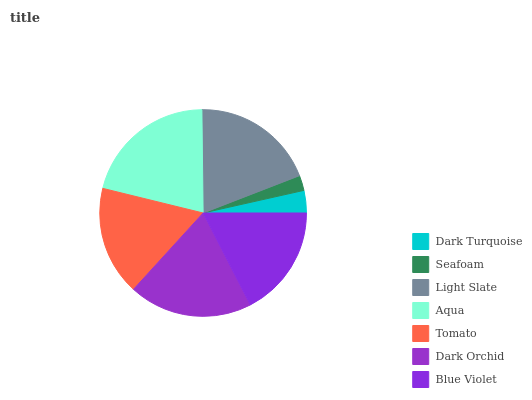Is Seafoam the minimum?
Answer yes or no. Yes. Is Aqua the maximum?
Answer yes or no. Yes. Is Light Slate the minimum?
Answer yes or no. No. Is Light Slate the maximum?
Answer yes or no. No. Is Light Slate greater than Seafoam?
Answer yes or no. Yes. Is Seafoam less than Light Slate?
Answer yes or no. Yes. Is Seafoam greater than Light Slate?
Answer yes or no. No. Is Light Slate less than Seafoam?
Answer yes or no. No. Is Blue Violet the high median?
Answer yes or no. Yes. Is Blue Violet the low median?
Answer yes or no. Yes. Is Light Slate the high median?
Answer yes or no. No. Is Light Slate the low median?
Answer yes or no. No. 